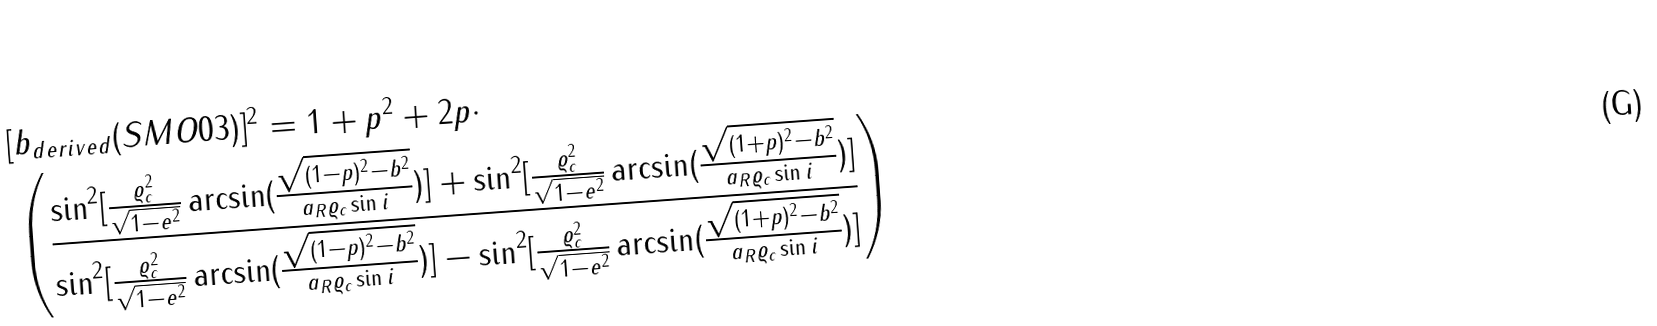Convert formula to latex. <formula><loc_0><loc_0><loc_500><loc_500>& [ b _ { d e r i v e d } ( S M O 0 3 ) ] ^ { 2 } = 1 + p ^ { 2 } + 2 p \cdot \\ & \left ( \frac { \sin ^ { 2 } [ \frac { \varrho _ { c } ^ { 2 } } { \sqrt { 1 - e ^ { 2 } } } \arcsin ( \frac { \sqrt { ( 1 - p ) ^ { 2 } - b ^ { 2 } } } { a _ { R } \varrho _ { c } \sin i } ) ] + \sin ^ { 2 } [ \frac { \varrho _ { c } ^ { 2 } } { \sqrt { 1 - e ^ { 2 } } } \arcsin ( \frac { \sqrt { ( 1 + p ) ^ { 2 } - b ^ { 2 } } } { a _ { R } \varrho _ { c } \sin i } ) ] } { \sin ^ { 2 } [ \frac { \varrho _ { c } ^ { 2 } } { \sqrt { 1 - e ^ { 2 } } } \arcsin ( \frac { \sqrt { ( 1 - p ) ^ { 2 } - b ^ { 2 } } } { a _ { R } \varrho _ { c } \sin i } ) ] - \sin ^ { 2 } [ \frac { \varrho _ { c } ^ { 2 } } { \sqrt { 1 - e ^ { 2 } } } \arcsin ( \frac { \sqrt { ( 1 + p ) ^ { 2 } - b ^ { 2 } } } { a _ { R } \varrho _ { c } \sin i } ) ] } \right )</formula> 